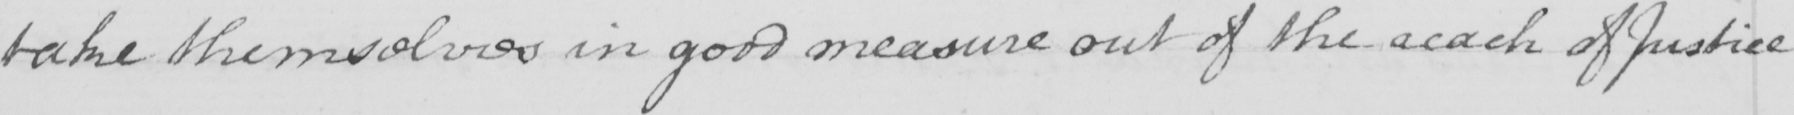Please provide the text content of this handwritten line. take themselves in good measure out of the reach of Justice 